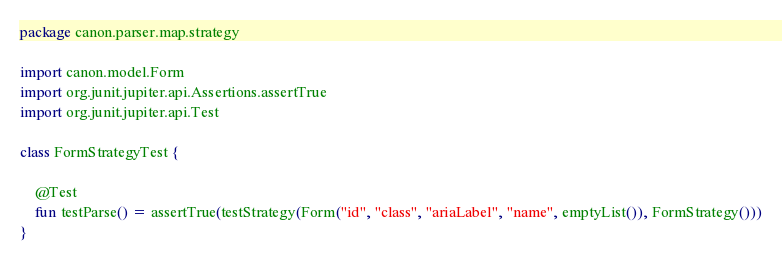<code> <loc_0><loc_0><loc_500><loc_500><_Kotlin_>package canon.parser.map.strategy

import canon.model.Form
import org.junit.jupiter.api.Assertions.assertTrue
import org.junit.jupiter.api.Test

class FormStrategyTest {

    @Test
    fun testParse() = assertTrue(testStrategy(Form("id", "class", "ariaLabel", "name", emptyList()), FormStrategy()))
}</code> 